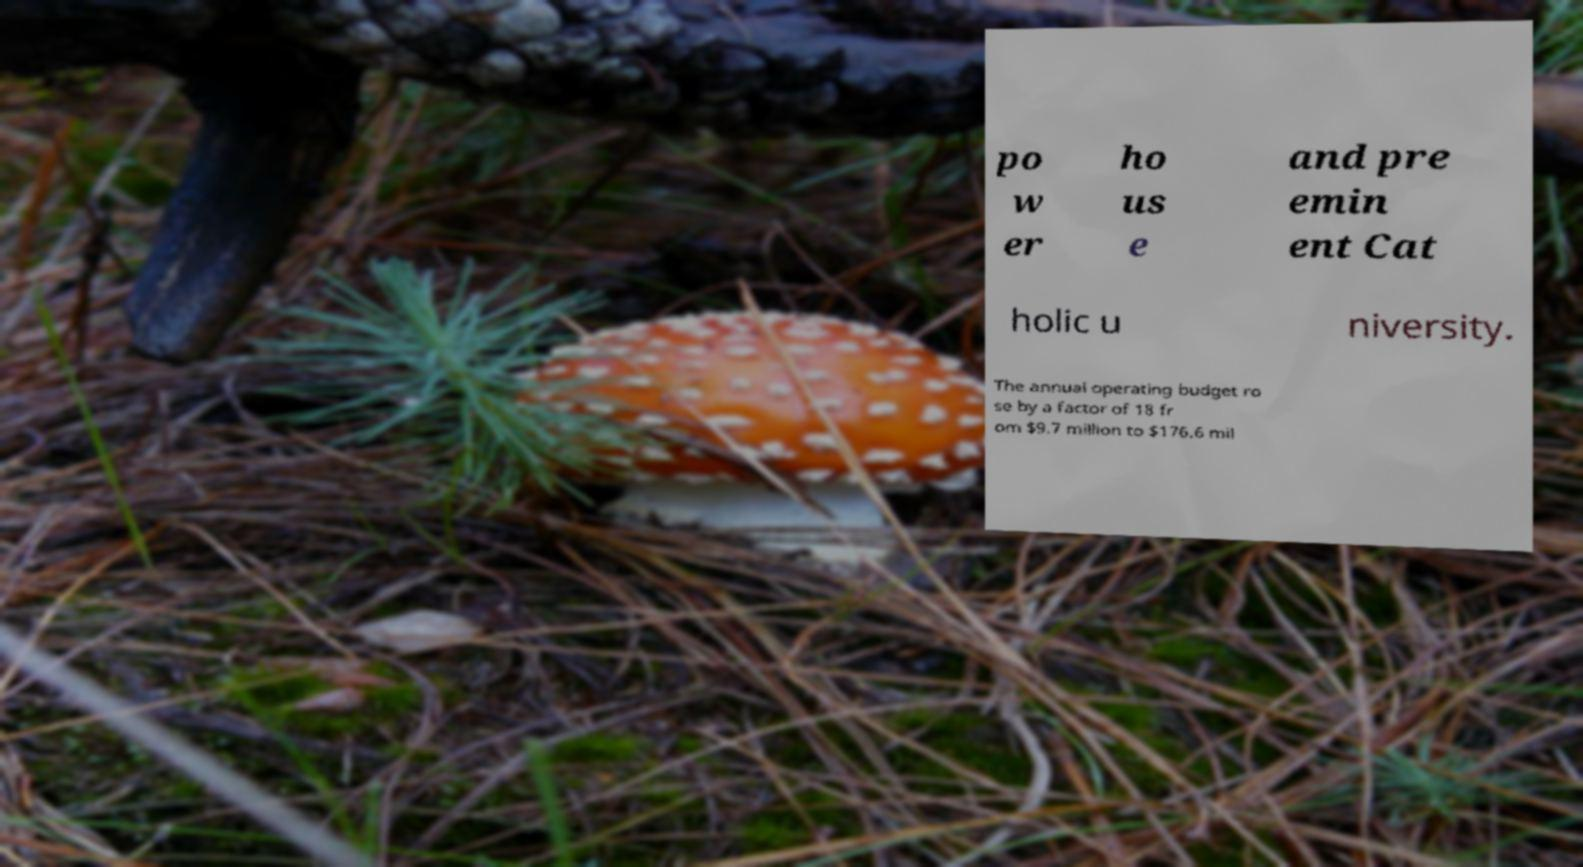I need the written content from this picture converted into text. Can you do that? po w er ho us e and pre emin ent Cat holic u niversity. The annual operating budget ro se by a factor of 18 fr om $9.7 million to $176.6 mil 